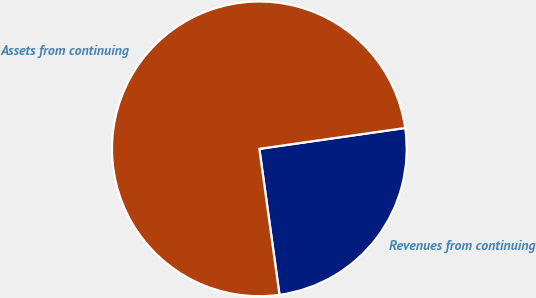<chart> <loc_0><loc_0><loc_500><loc_500><pie_chart><fcel>Revenues from continuing<fcel>Assets from continuing<nl><fcel>25.08%<fcel>74.92%<nl></chart> 